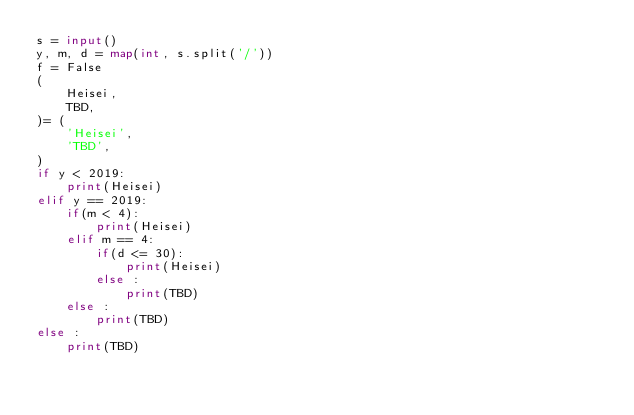<code> <loc_0><loc_0><loc_500><loc_500><_Python_>s = input()
y, m, d = map(int, s.split('/'))
f = False
(
    Heisei,
    TBD,
)= (
    'Heisei',
    'TBD',
)
if y < 2019:
    print(Heisei)
elif y == 2019:
    if(m < 4):
        print(Heisei)
    elif m == 4:
        if(d <= 30):
            print(Heisei)
        else :
            print(TBD)
    else :
        print(TBD)
else :
    print(TBD)</code> 